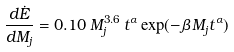Convert formula to latex. <formula><loc_0><loc_0><loc_500><loc_500>\frac { d \dot { E } } { d M _ { j } } = 0 . 1 0 \, M _ { j } ^ { 3 . 6 } \, t ^ { \alpha } \, { \exp } ( - { \beta } \, M _ { j } t ^ { \alpha } )</formula> 